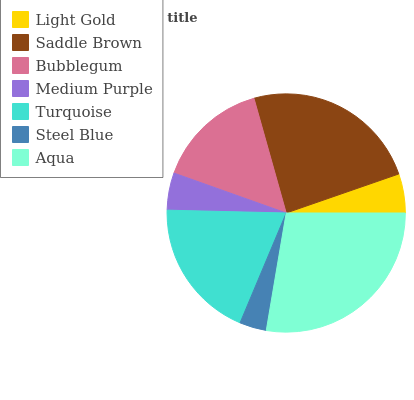Is Steel Blue the minimum?
Answer yes or no. Yes. Is Aqua the maximum?
Answer yes or no. Yes. Is Saddle Brown the minimum?
Answer yes or no. No. Is Saddle Brown the maximum?
Answer yes or no. No. Is Saddle Brown greater than Light Gold?
Answer yes or no. Yes. Is Light Gold less than Saddle Brown?
Answer yes or no. Yes. Is Light Gold greater than Saddle Brown?
Answer yes or no. No. Is Saddle Brown less than Light Gold?
Answer yes or no. No. Is Bubblegum the high median?
Answer yes or no. Yes. Is Bubblegum the low median?
Answer yes or no. Yes. Is Medium Purple the high median?
Answer yes or no. No. Is Medium Purple the low median?
Answer yes or no. No. 